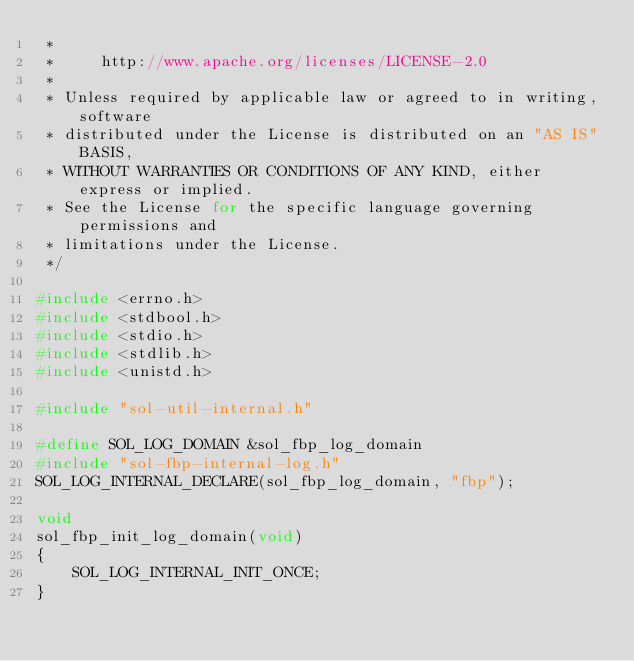<code> <loc_0><loc_0><loc_500><loc_500><_C_> *
 *     http://www.apache.org/licenses/LICENSE-2.0
 *
 * Unless required by applicable law or agreed to in writing, software
 * distributed under the License is distributed on an "AS IS" BASIS,
 * WITHOUT WARRANTIES OR CONDITIONS OF ANY KIND, either express or implied.
 * See the License for the specific language governing permissions and
 * limitations under the License.
 */

#include <errno.h>
#include <stdbool.h>
#include <stdio.h>
#include <stdlib.h>
#include <unistd.h>

#include "sol-util-internal.h"

#define SOL_LOG_DOMAIN &sol_fbp_log_domain
#include "sol-fbp-internal-log.h"
SOL_LOG_INTERNAL_DECLARE(sol_fbp_log_domain, "fbp");

void
sol_fbp_init_log_domain(void)
{
    SOL_LOG_INTERNAL_INIT_ONCE;
}
</code> 